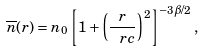Convert formula to latex. <formula><loc_0><loc_0><loc_500><loc_500>\overline { n } ( r ) = n _ { 0 } \left [ 1 + \left ( \frac { r } { \ r c } \right ) ^ { 2 } \right ] ^ { - 3 \beta / 2 } ,</formula> 